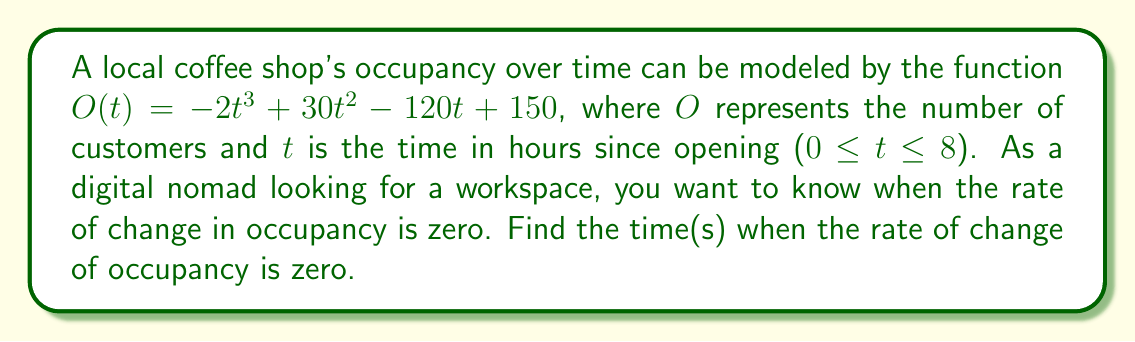Show me your answer to this math problem. To solve this problem, we need to follow these steps:

1) First, we need to find the derivative of the occupancy function $O(t)$. This will give us the rate of change of occupancy.

   $O(t) = -2t^3 + 30t^2 - 120t + 150$
   $O'(t) = -6t^2 + 60t - 120$

2) Now, we need to find when this rate of change is zero. This means setting $O'(t) = 0$ and solving for $t$.

   $-6t^2 + 60t - 120 = 0$

3) This is a quadratic equation. We can solve it using the quadratic formula:
   $t = \frac{-b \pm \sqrt{b^2 - 4ac}}{2a}$

   Where $a = -6$, $b = 60$, and $c = -120$

4) Substituting these values:

   $t = \frac{-60 \pm \sqrt{60^2 - 4(-6)(-120)}}{2(-6)}$
   $t = \frac{-60 \pm \sqrt{3600 - 2880}}{-12}$
   $t = \frac{-60 \pm \sqrt{720}}{-12}$
   $t = \frac{-60 \pm 2\sqrt{180}}{-12}$

5) Simplifying:

   $t = 5 \pm \frac{\sqrt{180}}{6}$
   $t = 5 \pm \frac{6\sqrt{5}}{6}$
   $t = 5 \pm \sqrt{5}$

6) Therefore, the rate of change of occupancy is zero at two times:

   $t_1 = 5 + \sqrt{5} \approx 7.24$ hours
   $t_2 = 5 - \sqrt{5} \approx 2.76$ hours

Both of these times fall within the shop's operating hours (0 ≤ t ≤ 8).
Answer: $t = 5 \pm \sqrt{5}$ hours 